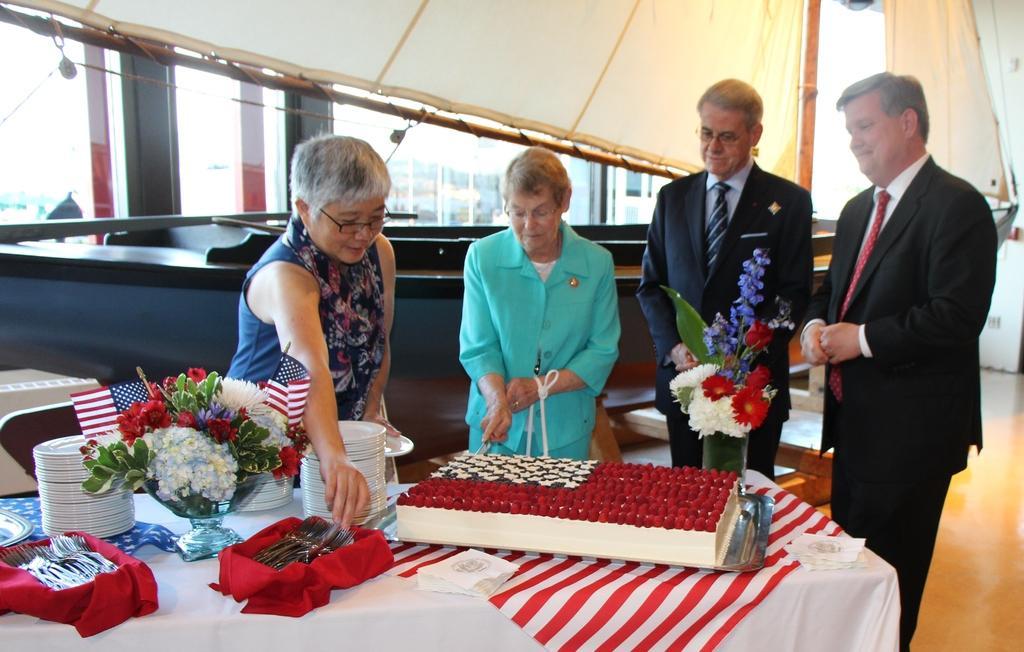Can you describe this image briefly? This picture is taken inside the room. In this image, in the middle, we can see four people is standing in front of the table, on the table, we can see a white colored cloth, a few plates, bowl, flowers, plant and a basket with some spoons. On the right side of the table, we can see a red color cloth and an object, tissues. In the background, we can see few tables and chairs. At the top, we can see a tent. In the background, we can see a glass window. 